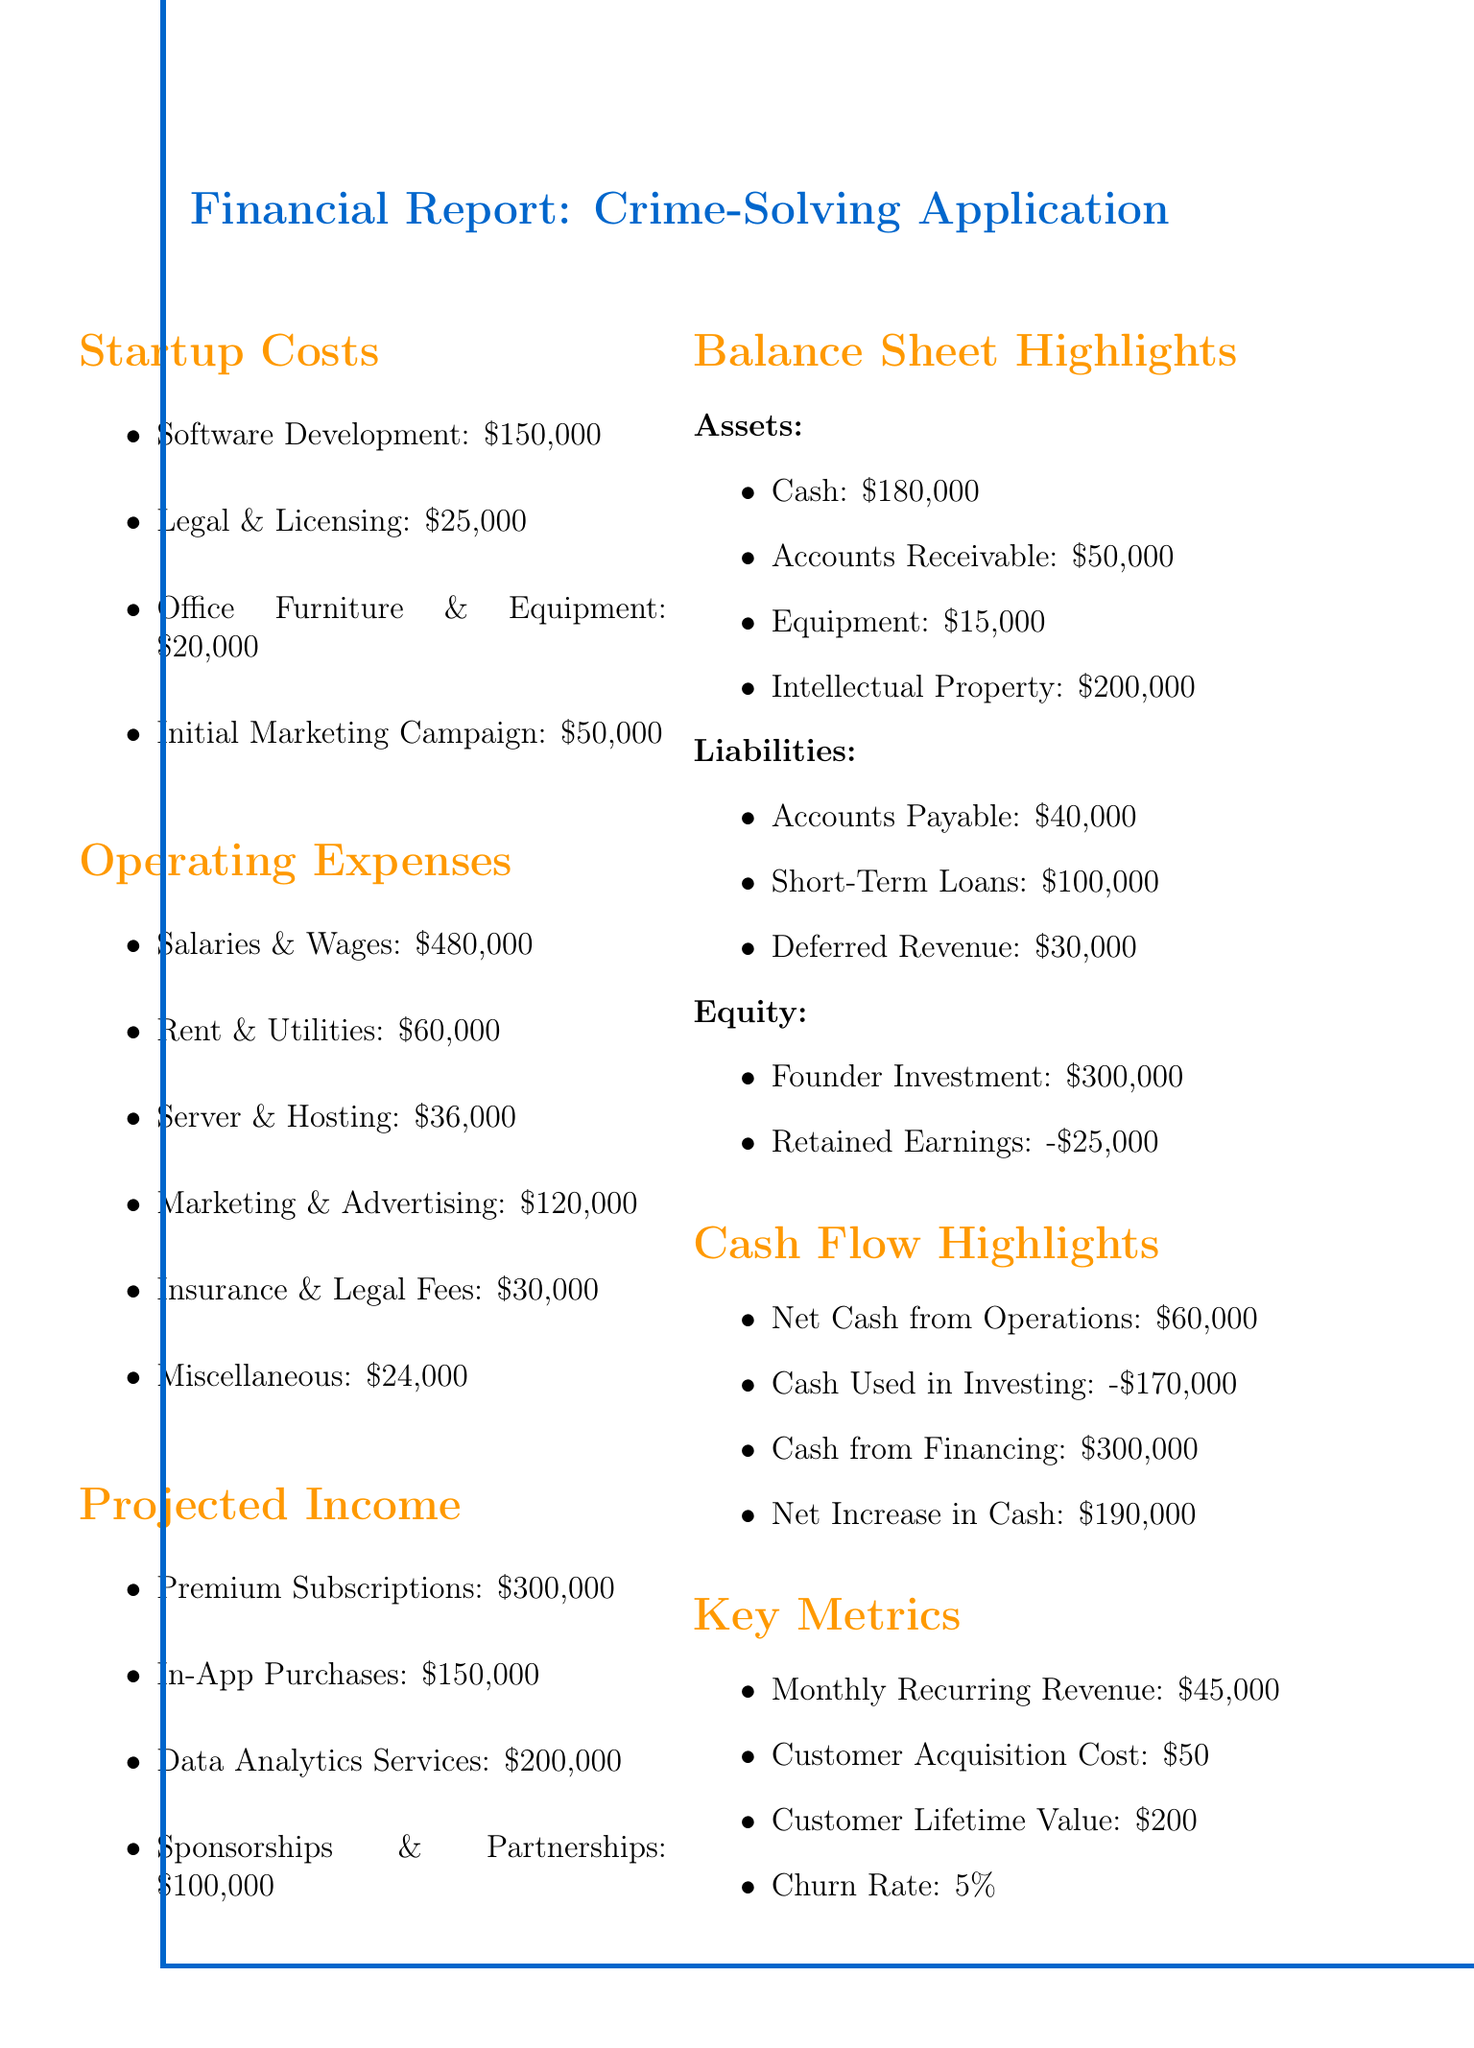What are the total startup costs? The total startup costs can be calculated by summing all startup expenses: 150000 + 25000 + 20000 + 50000 = 250000.
Answer: 250000 What is the total projected income? The total projected income is the sum of all income sources: 300000 + 150000 + 200000 + 100000 = 800000.
Answer: 800000 What is the cash on hand? The balance sheet states that the cash asset is 180000.
Answer: 180000 What is the total operating expenses? The total operating expenses can be calculated by summing all operating costs: 480000 + 60000 + 36000 + 120000 + 30000 + 24000 = 720000.
Answer: 720000 What is the net cash from operations? According to the cash flow highlights, the net cash from operations is stated as 60000.
Answer: 60000 What is the company's retained earnings? The balance sheet shows retained earnings as -25000.
Answer: -25000 What is the founder's investment? The equity section of the balance sheet lists the founder's investment as 300000.
Answer: 300000 What is the churn rate? The key metrics section indicates the churn rate is 5%.
Answer: 5% What is the customer acquisition cost? The document states the customer acquisition cost as 50.
Answer: 50 